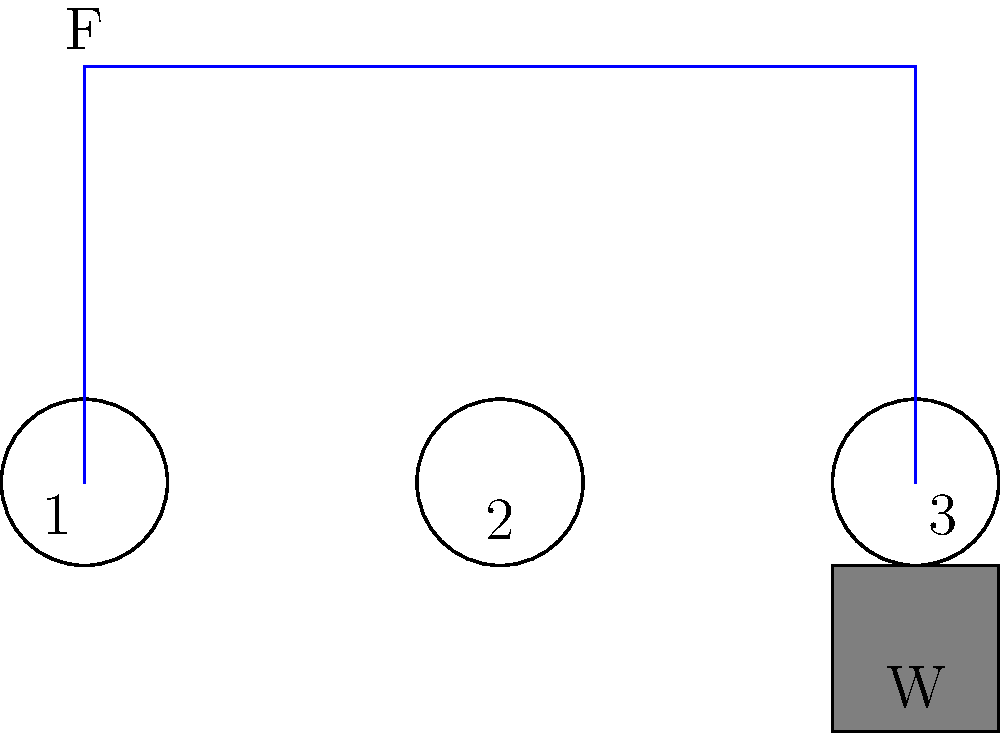In a factory during the Industrial Revolution, a pulley system is used to lift heavy loads. The system consists of three pulleys as shown in the diagram. If a weight $W$ of 600 N needs to be lifted, what is the minimum force $F$ required to raise the weight, assuming an ideal frictionless system? To solve this problem, we'll use the principle of mechanical advantage in a pulley system. Let's approach this step-by-step:

1) First, we need to identify the type of pulley system. This is a compound pulley system with three pulleys.

2) In an ideal pulley system, the mechanical advantage is equal to the number of rope segments supporting the weight. Let's count these segments:
   - There's one segment from pulley 3 to the weight
   - There's one segment between pulley 2 and pulley 3
   - There's one segment between pulley 1 and pulley 2
   
   Total: 3 segments

3) The mechanical advantage (MA) is therefore 3.

4) The relationship between the input force (F), the weight (W), and the mechanical advantage (MA) is:

   $MA = \frac{W}{F}$

5) Substituting our known values:

   $3 = \frac{600 N}{F}$

6) Solving for F:

   $F = \frac{600 N}{3} = 200 N$

Therefore, the minimum force required to lift the 600 N weight is 200 N.
Answer: 200 N 